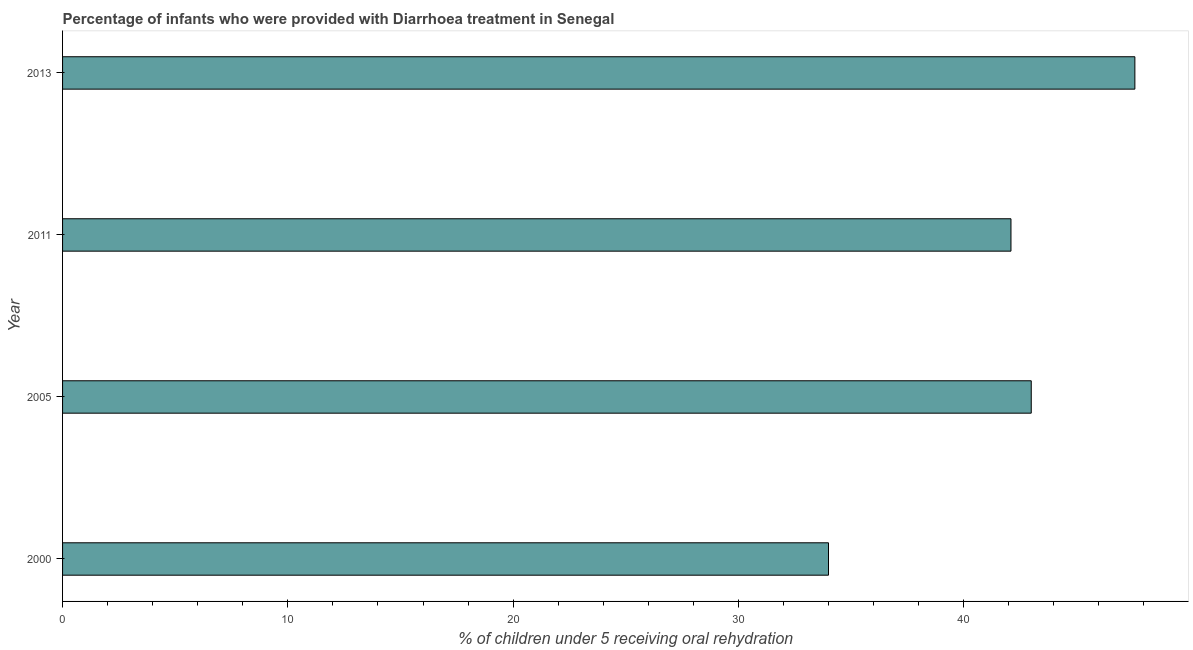What is the title of the graph?
Your response must be concise. Percentage of infants who were provided with Diarrhoea treatment in Senegal. What is the label or title of the X-axis?
Give a very brief answer. % of children under 5 receiving oral rehydration. What is the percentage of children who were provided with treatment diarrhoea in 2011?
Offer a very short reply. 42.1. Across all years, what is the maximum percentage of children who were provided with treatment diarrhoea?
Provide a short and direct response. 47.6. Across all years, what is the minimum percentage of children who were provided with treatment diarrhoea?
Your answer should be compact. 34. In which year was the percentage of children who were provided with treatment diarrhoea maximum?
Offer a terse response. 2013. What is the sum of the percentage of children who were provided with treatment diarrhoea?
Provide a short and direct response. 166.7. What is the average percentage of children who were provided with treatment diarrhoea per year?
Keep it short and to the point. 41.67. What is the median percentage of children who were provided with treatment diarrhoea?
Offer a very short reply. 42.55. In how many years, is the percentage of children who were provided with treatment diarrhoea greater than 12 %?
Offer a terse response. 4. Do a majority of the years between 2011 and 2005 (inclusive) have percentage of children who were provided with treatment diarrhoea greater than 30 %?
Make the answer very short. No. What is the ratio of the percentage of children who were provided with treatment diarrhoea in 2000 to that in 2005?
Your answer should be compact. 0.79. Is the percentage of children who were provided with treatment diarrhoea in 2000 less than that in 2011?
Keep it short and to the point. Yes. Is the difference between the percentage of children who were provided with treatment diarrhoea in 2000 and 2013 greater than the difference between any two years?
Make the answer very short. Yes. What is the difference between the highest and the second highest percentage of children who were provided with treatment diarrhoea?
Keep it short and to the point. 4.6. Is the sum of the percentage of children who were provided with treatment diarrhoea in 2005 and 2011 greater than the maximum percentage of children who were provided with treatment diarrhoea across all years?
Keep it short and to the point. Yes. What is the difference between the highest and the lowest percentage of children who were provided with treatment diarrhoea?
Provide a succinct answer. 13.6. In how many years, is the percentage of children who were provided with treatment diarrhoea greater than the average percentage of children who were provided with treatment diarrhoea taken over all years?
Your response must be concise. 3. Are all the bars in the graph horizontal?
Make the answer very short. Yes. How many years are there in the graph?
Give a very brief answer. 4. What is the difference between two consecutive major ticks on the X-axis?
Give a very brief answer. 10. What is the % of children under 5 receiving oral rehydration in 2000?
Offer a terse response. 34. What is the % of children under 5 receiving oral rehydration in 2011?
Provide a succinct answer. 42.1. What is the % of children under 5 receiving oral rehydration in 2013?
Give a very brief answer. 47.6. What is the difference between the % of children under 5 receiving oral rehydration in 2000 and 2011?
Make the answer very short. -8.1. What is the difference between the % of children under 5 receiving oral rehydration in 2000 and 2013?
Your response must be concise. -13.6. What is the difference between the % of children under 5 receiving oral rehydration in 2005 and 2011?
Offer a very short reply. 0.9. What is the difference between the % of children under 5 receiving oral rehydration in 2005 and 2013?
Your answer should be very brief. -4.6. What is the ratio of the % of children under 5 receiving oral rehydration in 2000 to that in 2005?
Make the answer very short. 0.79. What is the ratio of the % of children under 5 receiving oral rehydration in 2000 to that in 2011?
Provide a short and direct response. 0.81. What is the ratio of the % of children under 5 receiving oral rehydration in 2000 to that in 2013?
Ensure brevity in your answer.  0.71. What is the ratio of the % of children under 5 receiving oral rehydration in 2005 to that in 2011?
Provide a short and direct response. 1.02. What is the ratio of the % of children under 5 receiving oral rehydration in 2005 to that in 2013?
Keep it short and to the point. 0.9. What is the ratio of the % of children under 5 receiving oral rehydration in 2011 to that in 2013?
Offer a terse response. 0.88. 